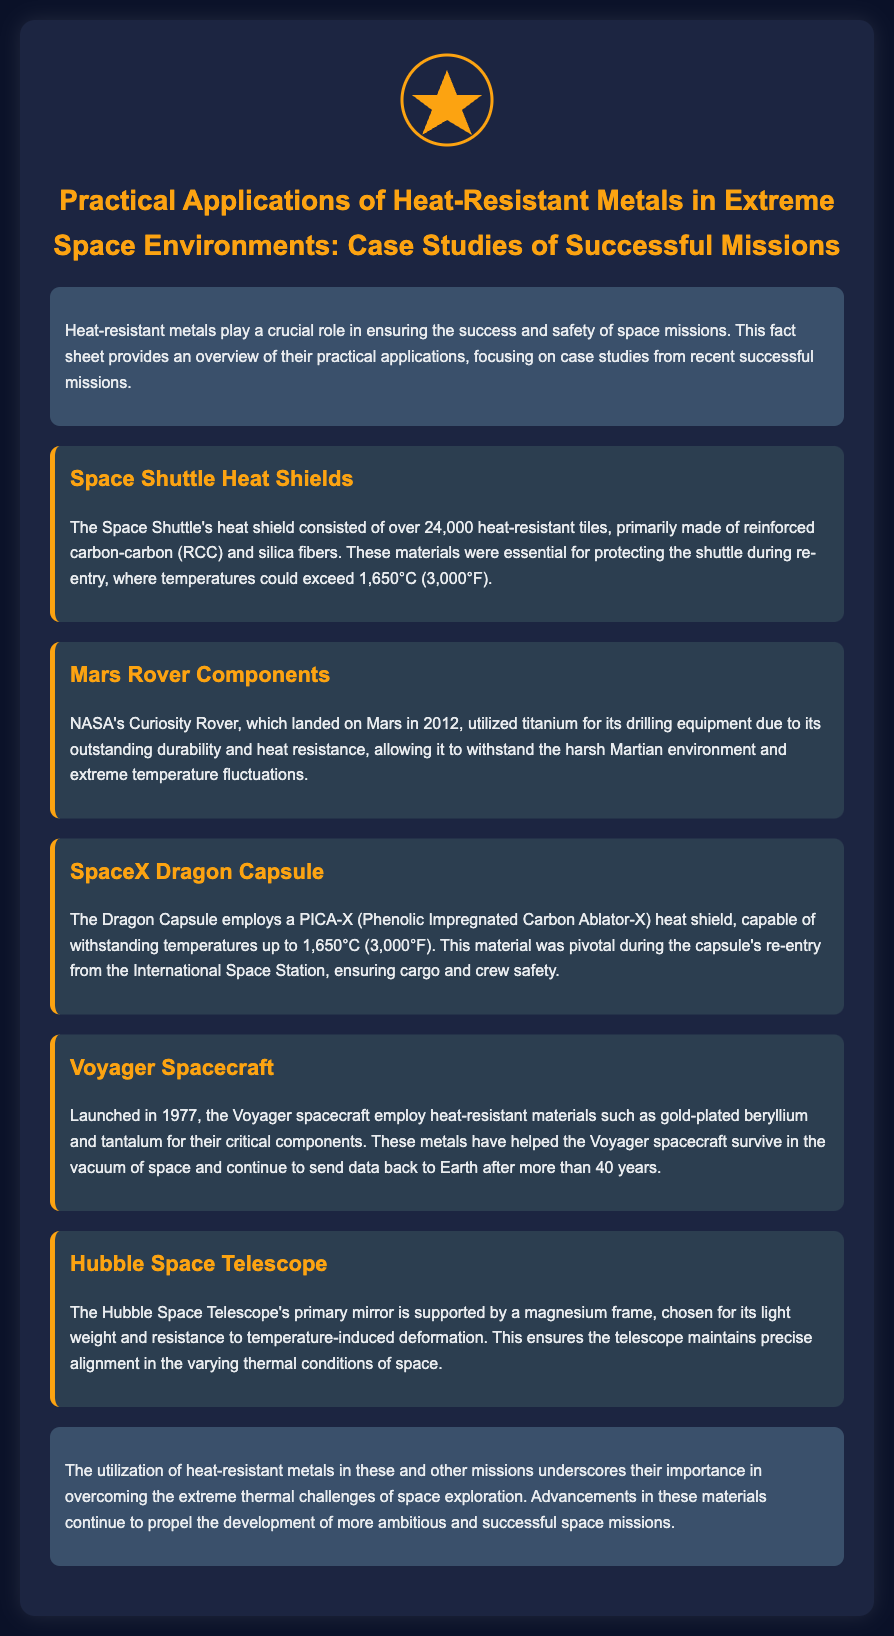What materials make up the Space Shuttle's heat shield? The Space Shuttle's heat shield is primarily made of reinforced carbon-carbon (RCC) and silica fibers.
Answer: RCC and silica fibers What temperature can the SpaceX Dragon Capsule's heat shield withstand? The Dragon Capsule's heat shield is capable of withstanding temperatures up to 1,650°C (3,000°F).
Answer: 1,650°C (3,000°F) Which rover utilized titanium for its drilling equipment? NASA's Curiosity Rover, which landed on Mars in 2012, utilized titanium for its drilling equipment due to its outstanding durability and heat resistance.
Answer: Curiosity Rover What year was the Voyager spacecraft launched? The Voyager spacecraft was launched in 1977.
Answer: 1977 What is the primary mirror of the Hubble Space Telescope supported by? The Hubble Space Telescope's primary mirror is supported by a magnesium frame.
Answer: Magnesium frame Why is titanium used in the Curiosity Rover? Titanium is used for its outstanding durability and heat resistance, allowing it to withstand the harsh Martian environment and extreme temperature fluctuations.
Answer: Durability and heat resistance How many heat-resistant tiles does the Space Shuttle have? The Space Shuttle's heat shield consisted of over 24,000 heat-resistant tiles.
Answer: 24,000 tiles What role do heat-resistant metals play in space missions? Heat-resistant metals are crucial for ensuring the success and safety of space missions, helping to overcome extreme thermal challenges.
Answer: Success and safety What is the primary focus of this fact sheet? The fact sheet provides an overview of the practical applications of heat-resistant metals, focusing on case studies from recent successful missions.
Answer: Practical applications 